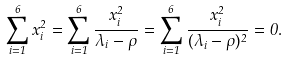Convert formula to latex. <formula><loc_0><loc_0><loc_500><loc_500>\sum _ { i = 1 } ^ { 6 } x _ { i } ^ { 2 } = \sum _ { i = 1 } ^ { 6 } \frac { x _ { i } ^ { 2 } } { \lambda _ { i } - \rho } = \sum _ { i = 1 } ^ { 6 } \frac { x _ { i } ^ { 2 } } { ( \lambda _ { i } - \rho ) ^ { 2 } } = 0 .</formula> 